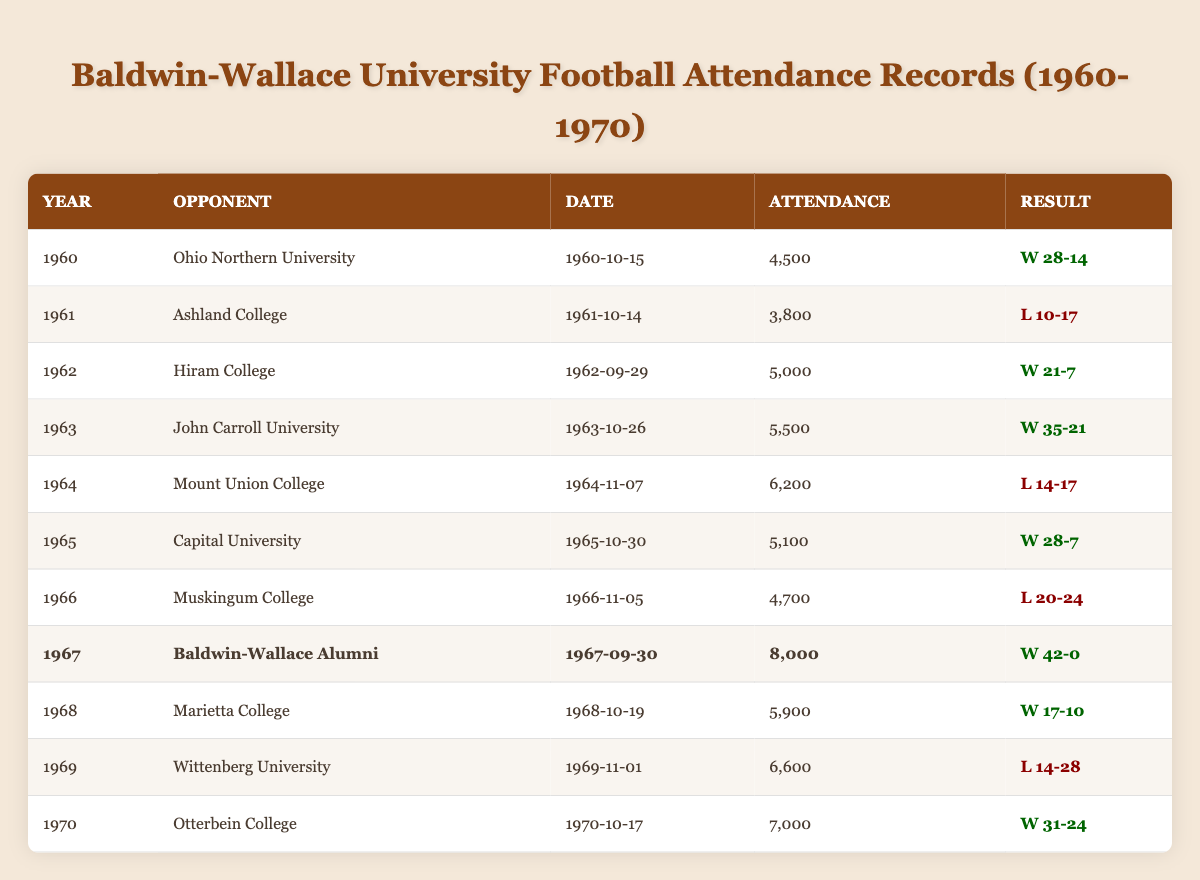What was the highest attendance recorded during the 1960-1970 football season? Looking at the attendance values in the table, the highest attendance is **8,000** in 1967 for the game against Baldwin-Wallace Alumni.
Answer: 8,000 Which opponent had the lowest attendance recorded in the 1960-1970 season? By comparing the attendance figures in the table, **3,800** against Ashland College in 1961 is the lowest.
Answer: 3,800 How many games did Baldwin-Wallace win in 1967? In 1967, the table indicates they played one game against Baldwin-Wallace Alumni, and they won that game. Therefore, they had **1 win** in that year.
Answer: 1 What is the average attendance over the ten years covered in the table? Adding all attendance figures (4,500 + 3,800 + 5,000 + 5,500 + 6,200 + 5,100 + 4,700 + 8,000 + 5,900 + 6,600 + 7,000 = 57,400) and dividing by 11 (total games) gives an average of **5,218.18**.
Answer: 5,218.18 Did Baldwin-Wallace University win more games than it lost in 1965? In 1965, the only game recorded was against Capital University, and Baldwin-Wallace won it, so they had **1 win** and **0 losses** that year. Thus, they won more.
Answer: Yes How many opponents had an attendance of 6,000 or more? From the table, three opponents had attendance figures of 6,000 or more: Mount Union College (6,200), Wittenberg University (6,600), and they had the highest of 8,000 against Baldwin-Wallace Alumni. So the total is **3 opponents**.
Answer: 3 What was the win-loss record for Baldwin-Wallace in 1964? In 1964, Baldwin-Wallace played only one game against Mount Union College, which they lost (L 14-17). This gives a record of **0 wins and 1 loss**.
Answer: 0 wins, 1 loss What percentage of games resulted in a win for Baldwin-Wallace from 1960 to 1970? Baldwin-Wallace won 6 of 11 games based on the results in the table. Therefore, the win percentage is (6/11) * 100, which is approximately **54.55%**.
Answer: 54.55% Which year had the most significant difference between attendance and the lowest attendance in that decade? The lowest attendance is 3,800 in 1961 and the highest is 8,000 in 1967. The difference is **8,000 - 3,800 = 4,200**.
Answer: 4,200 Was there a home game against John Carroll University? The table does not specify "home" or "away" games; it simply lists the opponents and results. Without that information, we cannot confirm if Baldwin-Wallace played John Carroll at home.
Answer: No (not specified) 